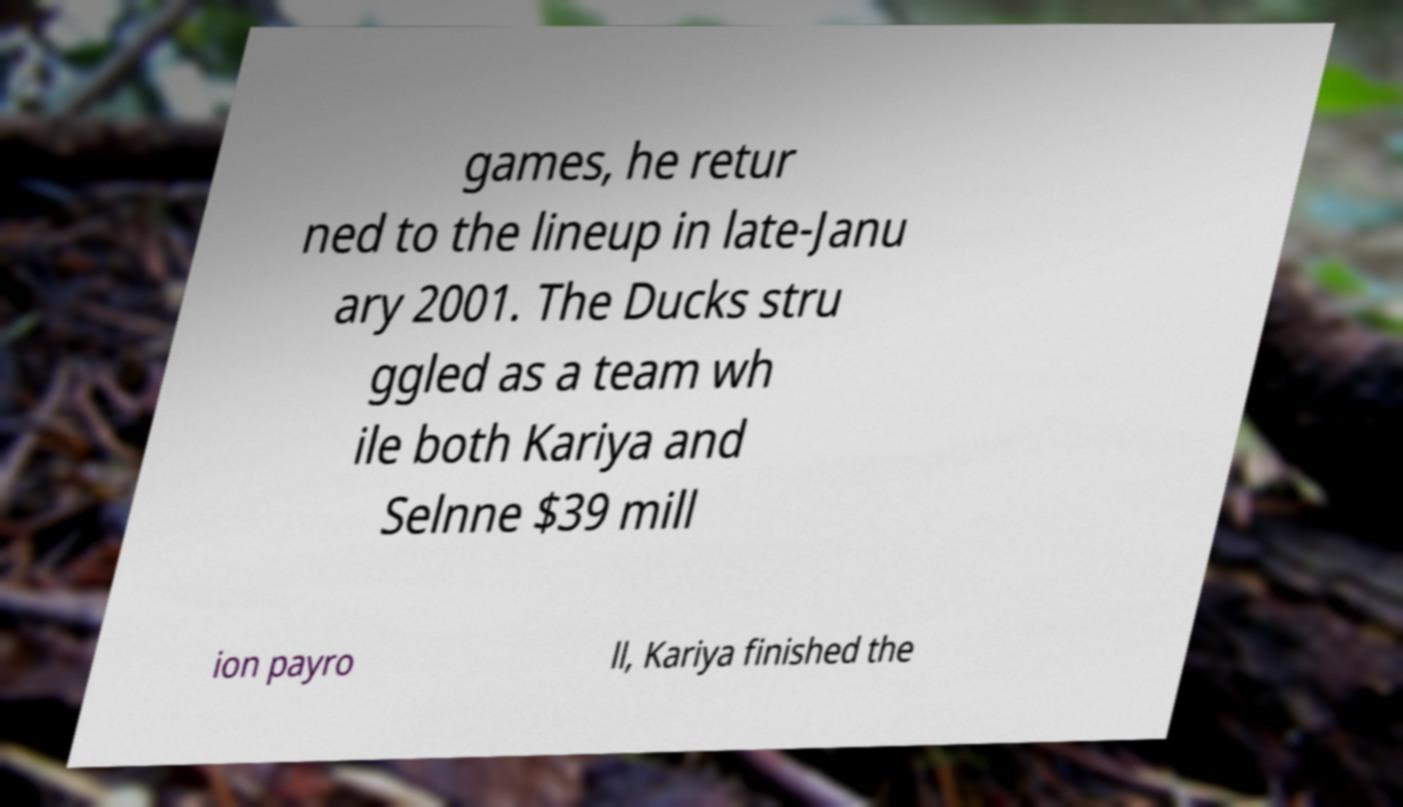For documentation purposes, I need the text within this image transcribed. Could you provide that? games, he retur ned to the lineup in late-Janu ary 2001. The Ducks stru ggled as a team wh ile both Kariya and Selnne $39 mill ion payro ll, Kariya finished the 